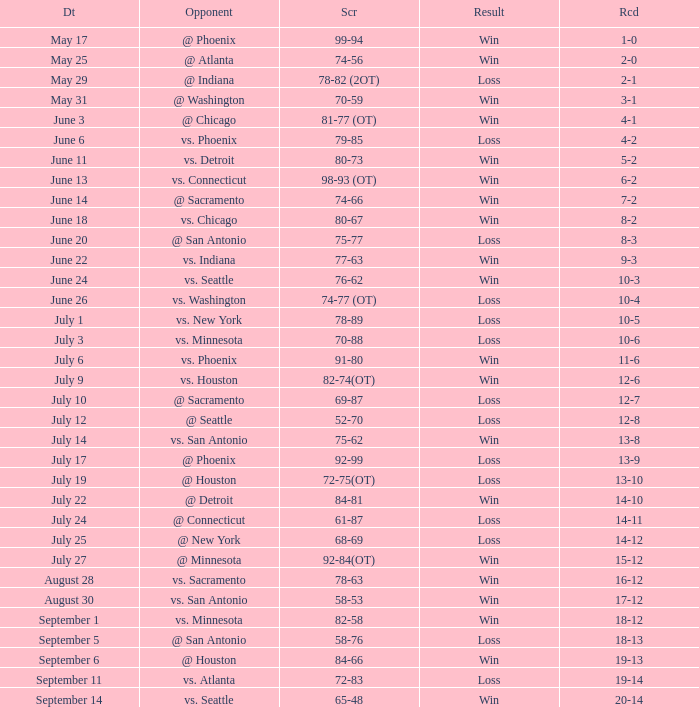What is the Record of the game on September 6? 19-13. 